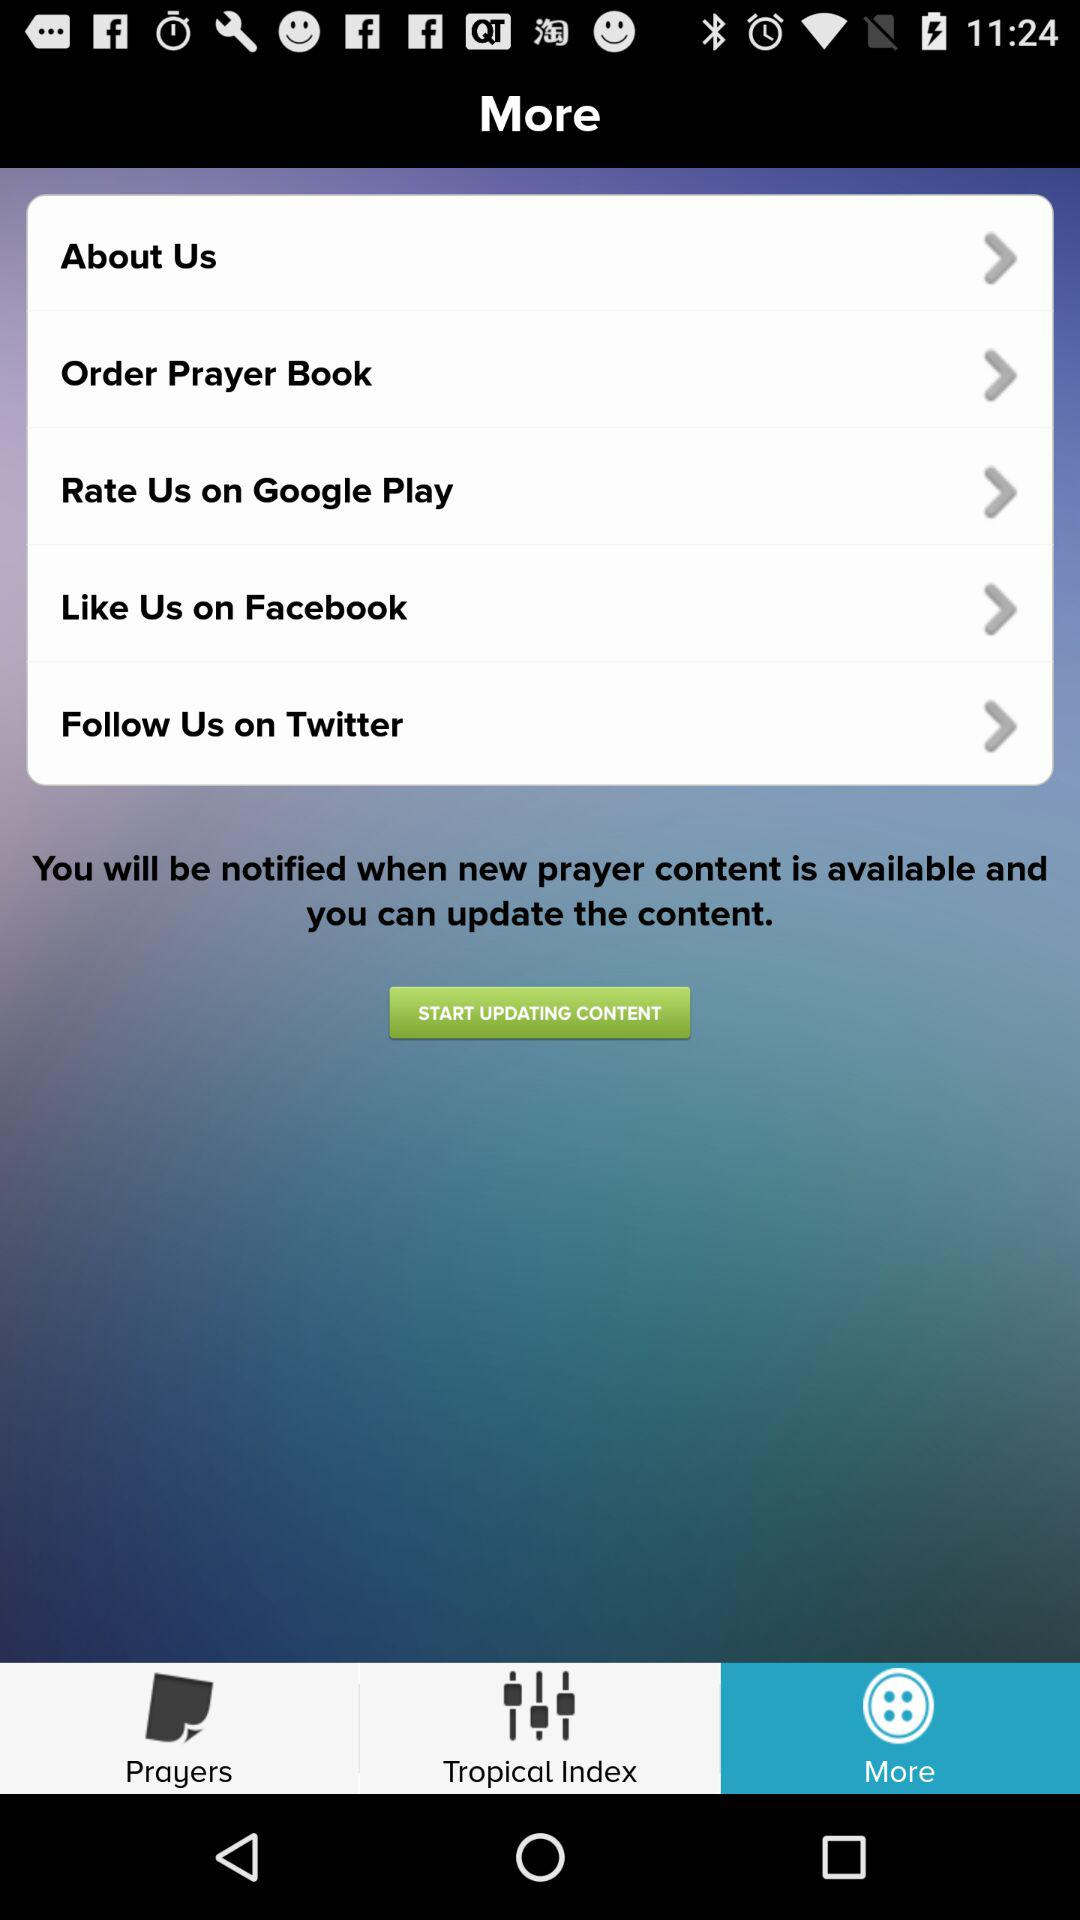Which tab is selected? The selected tab is "More". 